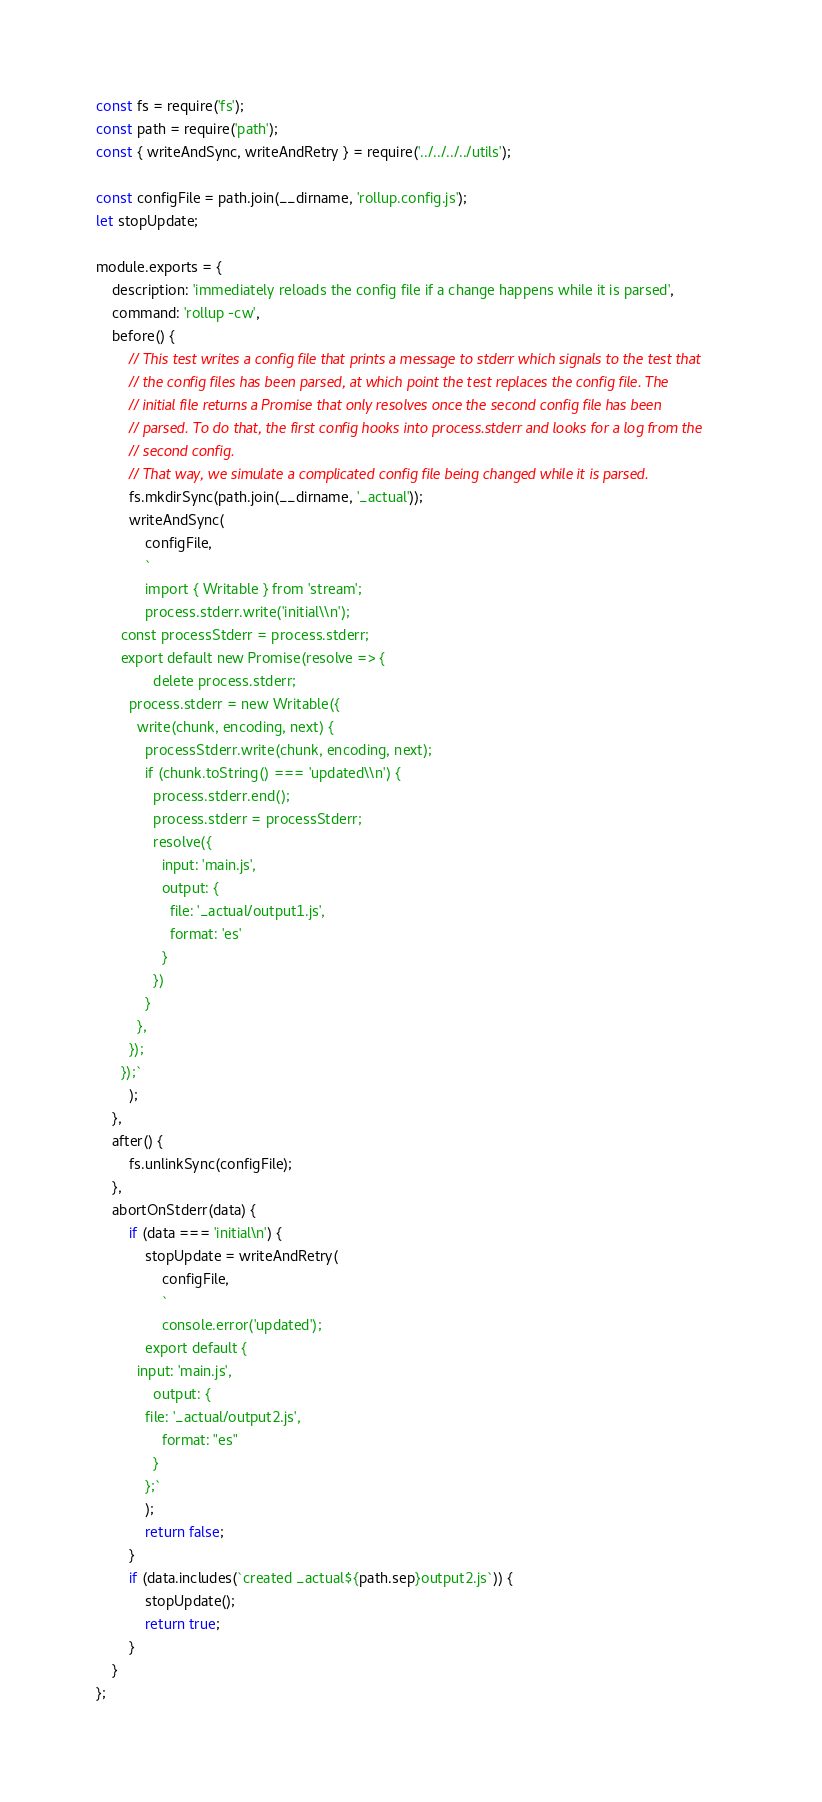Convert code to text. <code><loc_0><loc_0><loc_500><loc_500><_JavaScript_>const fs = require('fs');
const path = require('path');
const { writeAndSync, writeAndRetry } = require('../../../../utils');

const configFile = path.join(__dirname, 'rollup.config.js');
let stopUpdate;

module.exports = {
	description: 'immediately reloads the config file if a change happens while it is parsed',
	command: 'rollup -cw',
	before() {
		// This test writes a config file that prints a message to stderr which signals to the test that
		// the config files has been parsed, at which point the test replaces the config file. The
		// initial file returns a Promise that only resolves once the second config file has been
		// parsed. To do that, the first config hooks into process.stderr and looks for a log from the
		// second config.
		// That way, we simulate a complicated config file being changed while it is parsed.
		fs.mkdirSync(path.join(__dirname, '_actual'));
		writeAndSync(
			configFile,
			`
			import { Writable } from 'stream';
			process.stderr.write('initial\\n');
      const processStderr = process.stderr;
      export default new Promise(resolve => {
			  delete process.stderr;
        process.stderr = new Writable({
          write(chunk, encoding, next) {
            processStderr.write(chunk, encoding, next);
            if (chunk.toString() === 'updated\\n') {
              process.stderr.end();
              process.stderr = processStderr;
              resolve({
                input: 'main.js',
                output: {
                  file: '_actual/output1.js',
                  format: 'es'
                }
              })
            }
          },
        });
      });`
		);
	},
	after() {
		fs.unlinkSync(configFile);
	},
	abortOnStderr(data) {
		if (data === 'initial\n') {
			stopUpdate = writeAndRetry(
				configFile,
				`
				console.error('updated');
		    export default {
          input: 'main.js',
		      output: {
            file: '_actual/output2.js',
		        format: "es"
		      }
		    };`
			);
			return false;
		}
		if (data.includes(`created _actual${path.sep}output2.js`)) {
			stopUpdate();
			return true;
		}
	}
};
</code> 